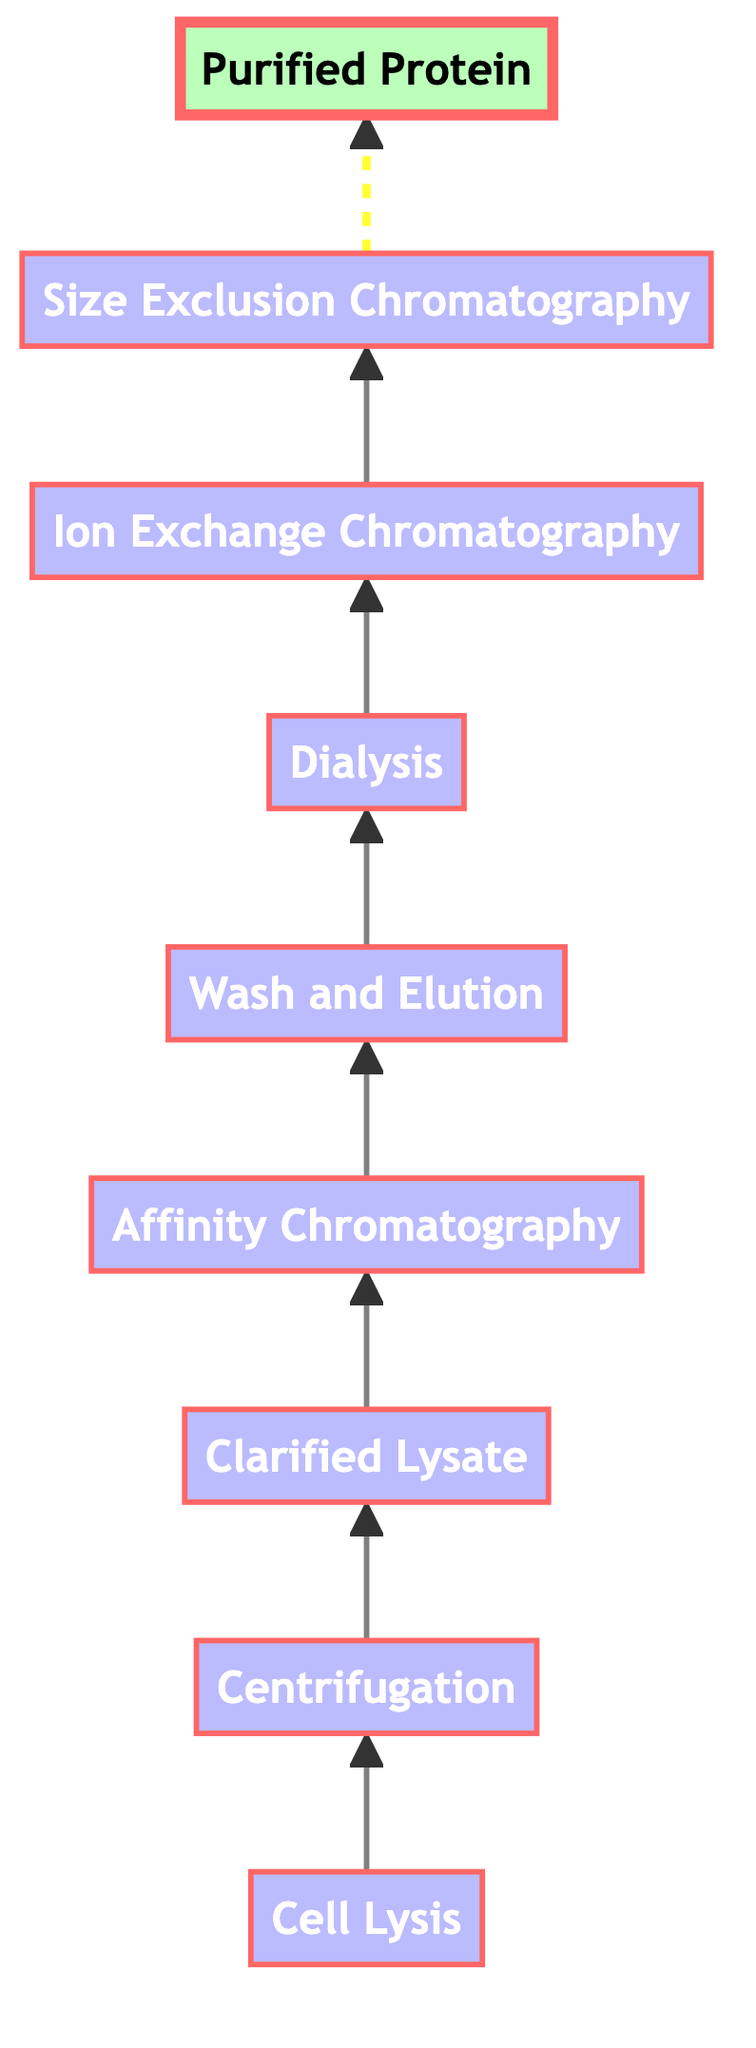What is the first step in the protein purification workflow? The flow chart starts with the node "Cell Lysis," indicating this is the first process in the purification workflow.
Answer: Cell Lysis What method is used for cell lysis? The diagram specifies "sonication, enzymatic digestion, or detergents" as the methods for breaking open cells.
Answer: Sonication, enzymatic digestion, or detergents How many total steps are there in the protein purification workflow? By counting the distinct nodes in the flow chart from "Cell Lysis" to "Purified Protein," there are a total of eight steps.
Answer: Eight What type of chromatography is used after centrifugation? Following "Centrifugation," the diagram shows "Affinity Chromatography" as the next step, indicating the type of chromatography used in the workflow.
Answer: Affinity Chromatography What is the purpose of dialysis in the workflow? The flow chart states that "Dialysis" is used for removing small molecules and salts from the protein solution, highlighting its purpose in the overall procedure.
Answer: Removing small molecules and salts Which step follows "Wash and Elution"? The flow chart indicates that "Dialysis" follows the "Wash and Elution" step, reflecting its sequential position in the purification process.
Answer: Dialysis What is the final product obtained at the end of the workflow? The diagram concludes with the node "Purified Protein," which names the final product after completing the purification steps.
Answer: Purified Protein Which chromatography step is utilized for further purification based on charge properties? The flow chart specifies "Ion Exchange Chromatography" as the step intended for additional purification based on the charge characteristics of the proteins.
Answer: Ion Exchange Chromatography How does this flow chart illustrate a bottom-to-top process? The directional arrows in the diagram point upwards, clearly indicating the sequence of steps moves from the base ("Cell Lysis") to the top ("Purified Protein") which visually represents the workflow progression.
Answer: Arrows point upwards 